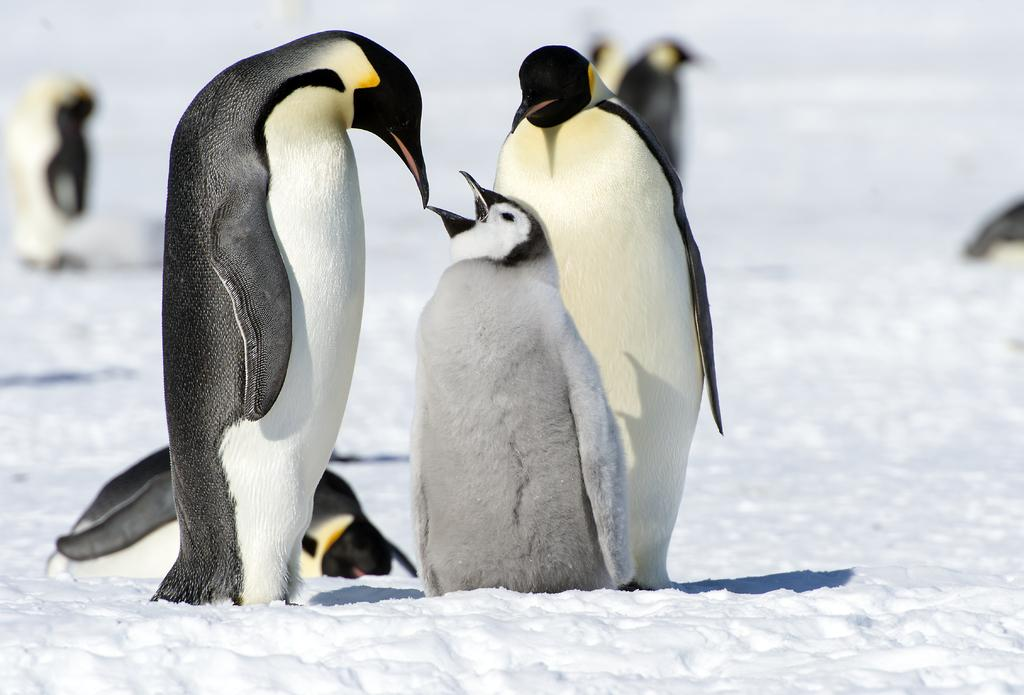What type of animals are present in the image? There are penguins in the image. What is the surface on which the penguins are standing? The penguins are on snow. How many letters are visible in the image? There are no letters present in the image; it features penguins on snow. What type of burst can be seen in the image? There is no burst present in the image; it features penguins on snow. 